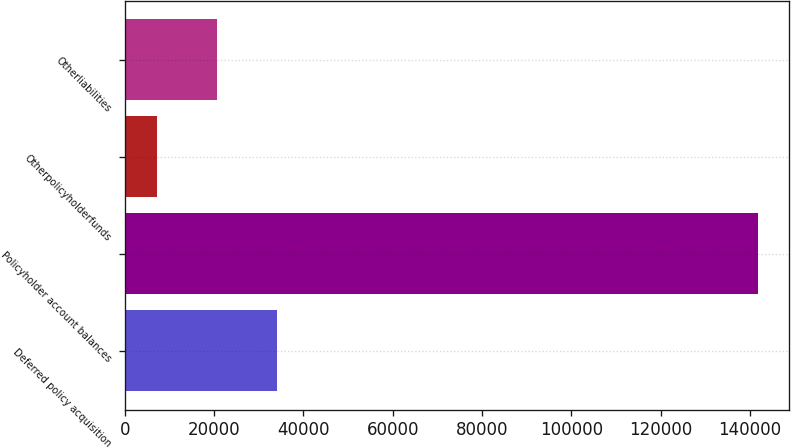Convert chart to OTSL. <chart><loc_0><loc_0><loc_500><loc_500><bar_chart><fcel>Deferred policy acquisition<fcel>Policyholder account balances<fcel>Otherpolicyholderfunds<fcel>Otherliabilities<nl><fcel>34088.2<fcel>141733<fcel>7177<fcel>20632.6<nl></chart> 